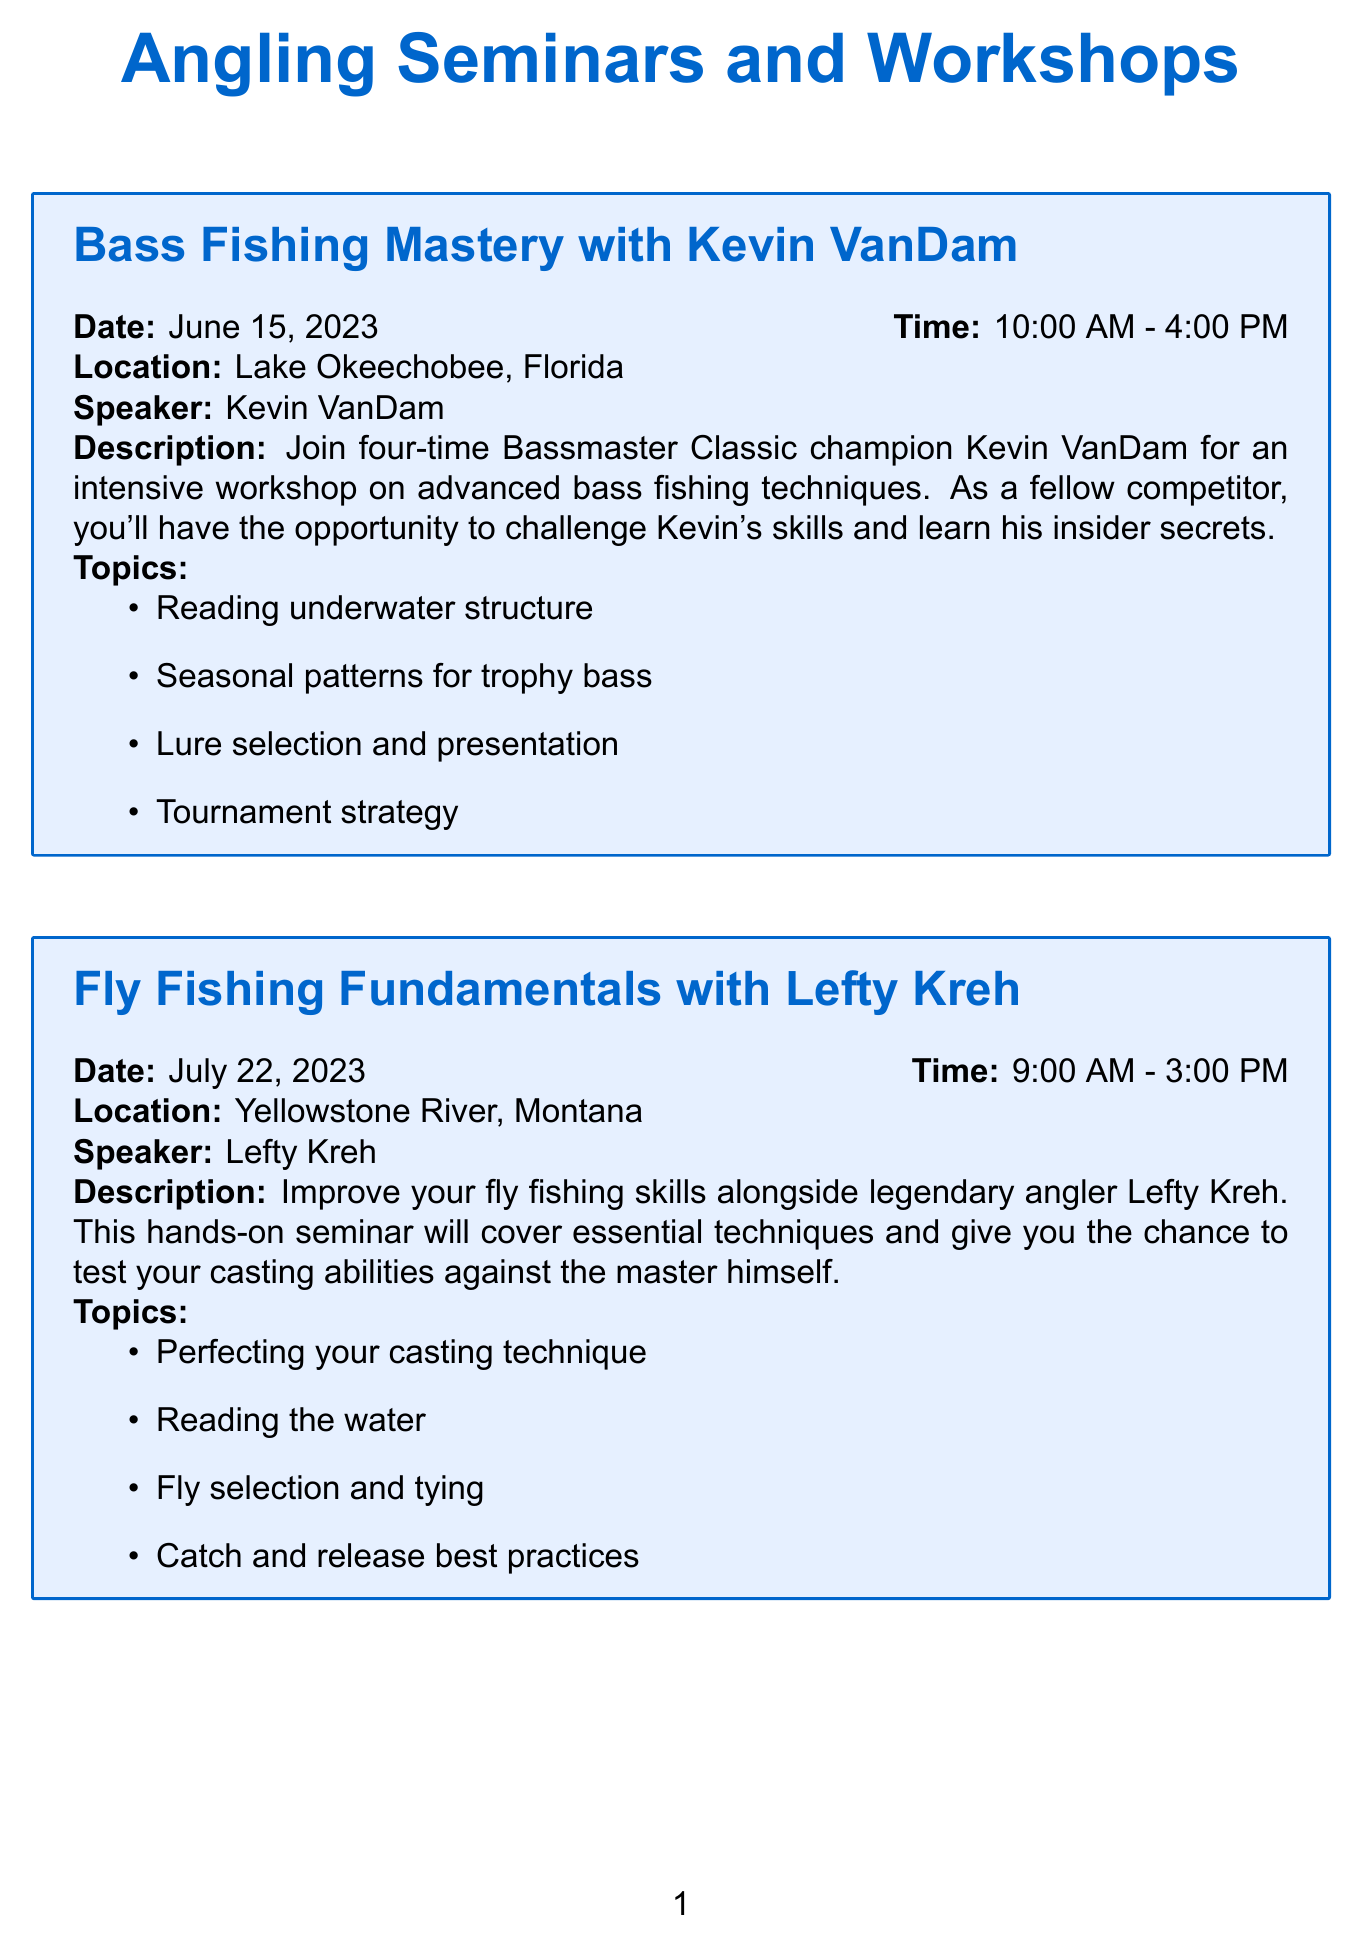What is the date of the "Bass Fishing Mastery" seminar? The date is specified in the document under the "Bass Fishing Mastery" section.
Answer: June 15, 2023 Who is the speaker for the "Ice Fishing Secrets" workshop? The speaker's name is mentioned in the "Ice Fishing Secrets" description.
Answer: Dave Genz What time does the "European Nymphing Masterclass" start? The start time is indicated in the "European Nymphing Masterclass" section.
Answer: 8:00 AM How long is the "Fly Fishing Fundamentals" seminar? The duration is calculated by subtracting the start time from the end time.
Answer: 6 hours What fishing technique is covered in "Saltwater Game Fish Tactics"? This is one of the topics listed under the "Saltwater Game Fish Tactics" section.
Answer: Trolling techniques for marlin and tuna Which location hosts the "Kayak Fishing Revolution" workshop? The location is provided in the workshop details for "Kayak Fishing Revolution".
Answer: La Jolla, California What are the topics covered in the "European Nymphing Masterclass"? The topics are listed, requiring identification of all mentioned.
Answer: Rigging for European nymphing, Proper leader construction, Reading water and trout lies, Fly selection and tying for nymphing What is the overall theme of the workshops? The theme can be inferred by considering all the topics addressed in the document.
Answer: Advanced fishing techniques 